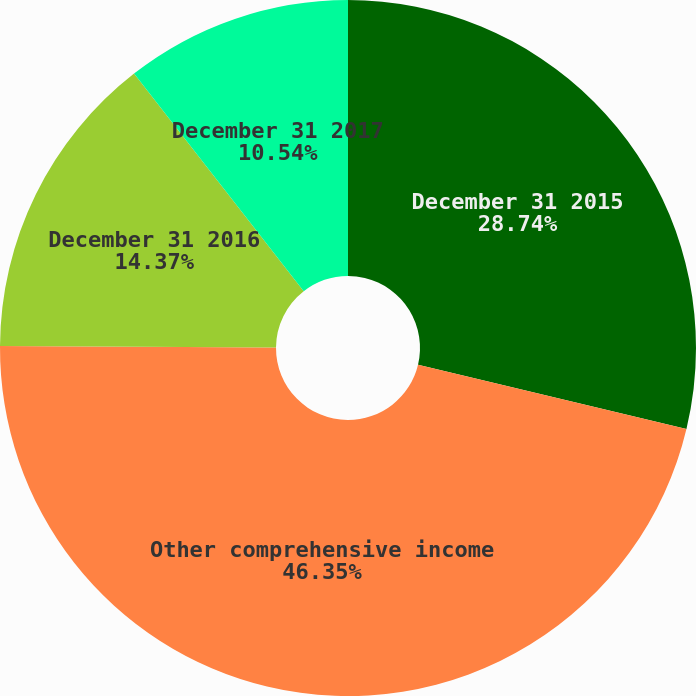Convert chart to OTSL. <chart><loc_0><loc_0><loc_500><loc_500><pie_chart><fcel>December 31 2015<fcel>Other comprehensive income<fcel>December 31 2016<fcel>December 31 2017<nl><fcel>28.74%<fcel>46.36%<fcel>14.37%<fcel>10.54%<nl></chart> 